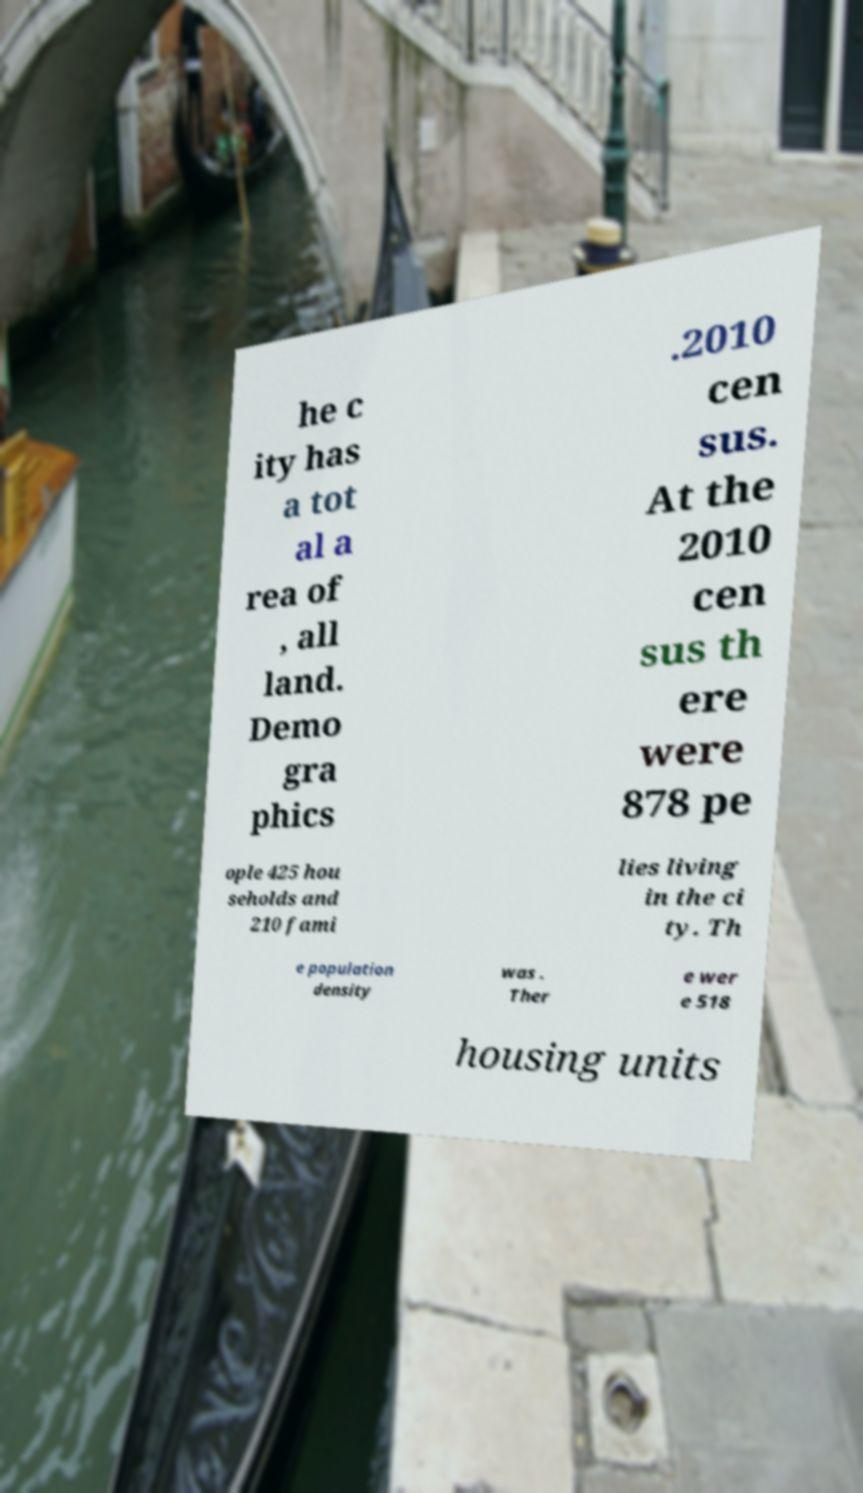Can you read and provide the text displayed in the image?This photo seems to have some interesting text. Can you extract and type it out for me? he c ity has a tot al a rea of , all land. Demo gra phics .2010 cen sus. At the 2010 cen sus th ere were 878 pe ople 425 hou seholds and 210 fami lies living in the ci ty. Th e population density was . Ther e wer e 518 housing units 